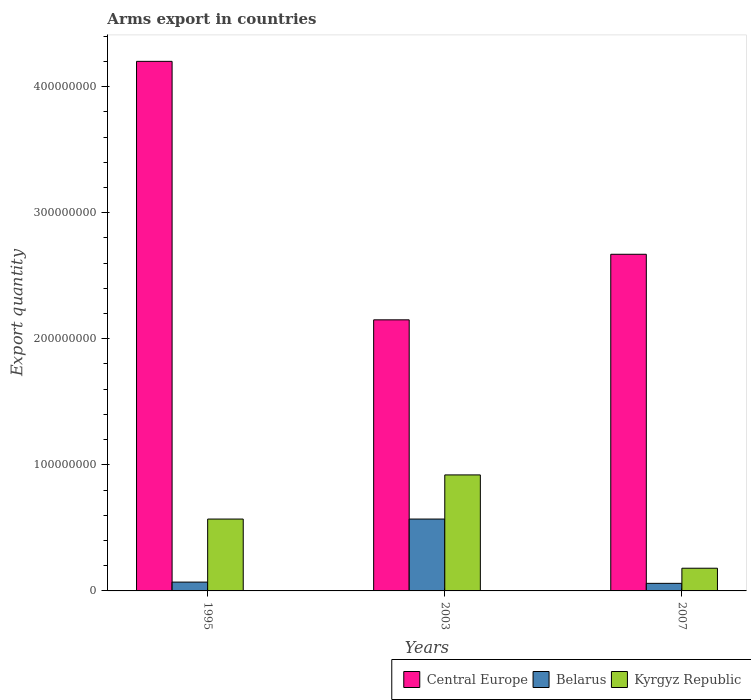How many different coloured bars are there?
Make the answer very short. 3. How many groups of bars are there?
Offer a very short reply. 3. Are the number of bars per tick equal to the number of legend labels?
Your answer should be very brief. Yes. Are the number of bars on each tick of the X-axis equal?
Give a very brief answer. Yes. How many bars are there on the 3rd tick from the right?
Keep it short and to the point. 3. In how many cases, is the number of bars for a given year not equal to the number of legend labels?
Keep it short and to the point. 0. What is the total arms export in Central Europe in 2007?
Offer a terse response. 2.67e+08. Across all years, what is the maximum total arms export in Belarus?
Keep it short and to the point. 5.70e+07. Across all years, what is the minimum total arms export in Kyrgyz Republic?
Make the answer very short. 1.80e+07. In which year was the total arms export in Belarus maximum?
Keep it short and to the point. 2003. What is the total total arms export in Kyrgyz Republic in the graph?
Offer a very short reply. 1.67e+08. What is the difference between the total arms export in Central Europe in 1995 and that in 2003?
Provide a succinct answer. 2.05e+08. What is the difference between the total arms export in Central Europe in 2007 and the total arms export in Kyrgyz Republic in 2003?
Give a very brief answer. 1.75e+08. What is the average total arms export in Kyrgyz Republic per year?
Give a very brief answer. 5.57e+07. In the year 2003, what is the difference between the total arms export in Belarus and total arms export in Central Europe?
Give a very brief answer. -1.58e+08. In how many years, is the total arms export in Kyrgyz Republic greater than 300000000?
Give a very brief answer. 0. What is the ratio of the total arms export in Kyrgyz Republic in 2003 to that in 2007?
Your response must be concise. 5.11. Is the difference between the total arms export in Belarus in 2003 and 2007 greater than the difference between the total arms export in Central Europe in 2003 and 2007?
Make the answer very short. Yes. What is the difference between the highest and the second highest total arms export in Central Europe?
Your answer should be very brief. 1.53e+08. What is the difference between the highest and the lowest total arms export in Belarus?
Offer a terse response. 5.10e+07. What does the 3rd bar from the left in 2007 represents?
Provide a short and direct response. Kyrgyz Republic. What does the 2nd bar from the right in 1995 represents?
Your answer should be very brief. Belarus. Is it the case that in every year, the sum of the total arms export in Kyrgyz Republic and total arms export in Belarus is greater than the total arms export in Central Europe?
Provide a succinct answer. No. How many bars are there?
Provide a short and direct response. 9. Are all the bars in the graph horizontal?
Your answer should be very brief. No. Does the graph contain grids?
Offer a very short reply. No. How many legend labels are there?
Give a very brief answer. 3. How are the legend labels stacked?
Provide a succinct answer. Horizontal. What is the title of the graph?
Offer a terse response. Arms export in countries. Does "Antigua and Barbuda" appear as one of the legend labels in the graph?
Keep it short and to the point. No. What is the label or title of the Y-axis?
Your answer should be very brief. Export quantity. What is the Export quantity of Central Europe in 1995?
Ensure brevity in your answer.  4.20e+08. What is the Export quantity in Belarus in 1995?
Provide a succinct answer. 7.00e+06. What is the Export quantity of Kyrgyz Republic in 1995?
Offer a terse response. 5.70e+07. What is the Export quantity of Central Europe in 2003?
Provide a succinct answer. 2.15e+08. What is the Export quantity in Belarus in 2003?
Keep it short and to the point. 5.70e+07. What is the Export quantity of Kyrgyz Republic in 2003?
Give a very brief answer. 9.20e+07. What is the Export quantity of Central Europe in 2007?
Provide a short and direct response. 2.67e+08. What is the Export quantity in Belarus in 2007?
Provide a short and direct response. 6.00e+06. What is the Export quantity of Kyrgyz Republic in 2007?
Make the answer very short. 1.80e+07. Across all years, what is the maximum Export quantity of Central Europe?
Keep it short and to the point. 4.20e+08. Across all years, what is the maximum Export quantity of Belarus?
Provide a succinct answer. 5.70e+07. Across all years, what is the maximum Export quantity of Kyrgyz Republic?
Give a very brief answer. 9.20e+07. Across all years, what is the minimum Export quantity of Central Europe?
Your answer should be compact. 2.15e+08. Across all years, what is the minimum Export quantity in Kyrgyz Republic?
Offer a very short reply. 1.80e+07. What is the total Export quantity in Central Europe in the graph?
Provide a short and direct response. 9.02e+08. What is the total Export quantity in Belarus in the graph?
Give a very brief answer. 7.00e+07. What is the total Export quantity of Kyrgyz Republic in the graph?
Your answer should be very brief. 1.67e+08. What is the difference between the Export quantity of Central Europe in 1995 and that in 2003?
Keep it short and to the point. 2.05e+08. What is the difference between the Export quantity in Belarus in 1995 and that in 2003?
Make the answer very short. -5.00e+07. What is the difference between the Export quantity in Kyrgyz Republic in 1995 and that in 2003?
Make the answer very short. -3.50e+07. What is the difference between the Export quantity of Central Europe in 1995 and that in 2007?
Offer a very short reply. 1.53e+08. What is the difference between the Export quantity in Belarus in 1995 and that in 2007?
Your response must be concise. 1.00e+06. What is the difference between the Export quantity in Kyrgyz Republic in 1995 and that in 2007?
Give a very brief answer. 3.90e+07. What is the difference between the Export quantity of Central Europe in 2003 and that in 2007?
Ensure brevity in your answer.  -5.20e+07. What is the difference between the Export quantity in Belarus in 2003 and that in 2007?
Offer a very short reply. 5.10e+07. What is the difference between the Export quantity in Kyrgyz Republic in 2003 and that in 2007?
Offer a very short reply. 7.40e+07. What is the difference between the Export quantity in Central Europe in 1995 and the Export quantity in Belarus in 2003?
Ensure brevity in your answer.  3.63e+08. What is the difference between the Export quantity of Central Europe in 1995 and the Export quantity of Kyrgyz Republic in 2003?
Make the answer very short. 3.28e+08. What is the difference between the Export quantity of Belarus in 1995 and the Export quantity of Kyrgyz Republic in 2003?
Keep it short and to the point. -8.50e+07. What is the difference between the Export quantity of Central Europe in 1995 and the Export quantity of Belarus in 2007?
Offer a terse response. 4.14e+08. What is the difference between the Export quantity in Central Europe in 1995 and the Export quantity in Kyrgyz Republic in 2007?
Your response must be concise. 4.02e+08. What is the difference between the Export quantity of Belarus in 1995 and the Export quantity of Kyrgyz Republic in 2007?
Your response must be concise. -1.10e+07. What is the difference between the Export quantity in Central Europe in 2003 and the Export quantity in Belarus in 2007?
Ensure brevity in your answer.  2.09e+08. What is the difference between the Export quantity of Central Europe in 2003 and the Export quantity of Kyrgyz Republic in 2007?
Provide a short and direct response. 1.97e+08. What is the difference between the Export quantity in Belarus in 2003 and the Export quantity in Kyrgyz Republic in 2007?
Offer a terse response. 3.90e+07. What is the average Export quantity of Central Europe per year?
Your response must be concise. 3.01e+08. What is the average Export quantity of Belarus per year?
Keep it short and to the point. 2.33e+07. What is the average Export quantity of Kyrgyz Republic per year?
Your answer should be compact. 5.57e+07. In the year 1995, what is the difference between the Export quantity in Central Europe and Export quantity in Belarus?
Your answer should be very brief. 4.13e+08. In the year 1995, what is the difference between the Export quantity of Central Europe and Export quantity of Kyrgyz Republic?
Keep it short and to the point. 3.63e+08. In the year 1995, what is the difference between the Export quantity of Belarus and Export quantity of Kyrgyz Republic?
Keep it short and to the point. -5.00e+07. In the year 2003, what is the difference between the Export quantity in Central Europe and Export quantity in Belarus?
Your answer should be very brief. 1.58e+08. In the year 2003, what is the difference between the Export quantity in Central Europe and Export quantity in Kyrgyz Republic?
Keep it short and to the point. 1.23e+08. In the year 2003, what is the difference between the Export quantity in Belarus and Export quantity in Kyrgyz Republic?
Provide a short and direct response. -3.50e+07. In the year 2007, what is the difference between the Export quantity in Central Europe and Export quantity in Belarus?
Ensure brevity in your answer.  2.61e+08. In the year 2007, what is the difference between the Export quantity in Central Europe and Export quantity in Kyrgyz Republic?
Give a very brief answer. 2.49e+08. In the year 2007, what is the difference between the Export quantity of Belarus and Export quantity of Kyrgyz Republic?
Your response must be concise. -1.20e+07. What is the ratio of the Export quantity of Central Europe in 1995 to that in 2003?
Provide a short and direct response. 1.95. What is the ratio of the Export quantity of Belarus in 1995 to that in 2003?
Your answer should be very brief. 0.12. What is the ratio of the Export quantity in Kyrgyz Republic in 1995 to that in 2003?
Make the answer very short. 0.62. What is the ratio of the Export quantity of Central Europe in 1995 to that in 2007?
Give a very brief answer. 1.57. What is the ratio of the Export quantity in Belarus in 1995 to that in 2007?
Offer a very short reply. 1.17. What is the ratio of the Export quantity in Kyrgyz Republic in 1995 to that in 2007?
Offer a terse response. 3.17. What is the ratio of the Export quantity of Central Europe in 2003 to that in 2007?
Your response must be concise. 0.81. What is the ratio of the Export quantity of Kyrgyz Republic in 2003 to that in 2007?
Provide a succinct answer. 5.11. What is the difference between the highest and the second highest Export quantity of Central Europe?
Provide a short and direct response. 1.53e+08. What is the difference between the highest and the second highest Export quantity of Belarus?
Keep it short and to the point. 5.00e+07. What is the difference between the highest and the second highest Export quantity of Kyrgyz Republic?
Give a very brief answer. 3.50e+07. What is the difference between the highest and the lowest Export quantity in Central Europe?
Your answer should be compact. 2.05e+08. What is the difference between the highest and the lowest Export quantity of Belarus?
Your answer should be compact. 5.10e+07. What is the difference between the highest and the lowest Export quantity in Kyrgyz Republic?
Your answer should be very brief. 7.40e+07. 